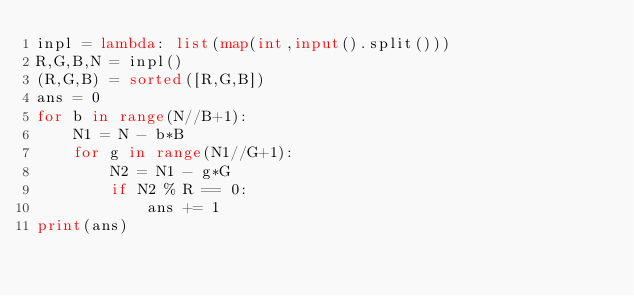Convert code to text. <code><loc_0><loc_0><loc_500><loc_500><_Python_>inpl = lambda: list(map(int,input().split()))
R,G,B,N = inpl()
(R,G,B) = sorted([R,G,B])
ans = 0
for b in range(N//B+1):
    N1 = N - b*B
    for g in range(N1//G+1):
        N2 = N1 - g*G
        if N2 % R == 0:
            ans += 1
print(ans)</code> 